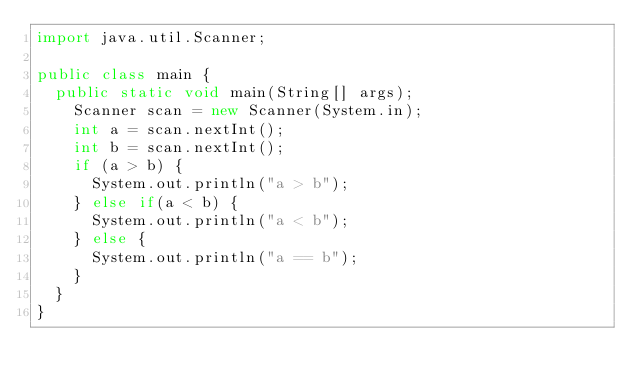Convert code to text. <code><loc_0><loc_0><loc_500><loc_500><_Java_>import java.util.Scanner;
  
public class main {
  public static void main(String[] args);
    Scanner scan = new Scanner(System.in);
    int a = scan.nextInt();
    int b = scan.nextInt();
    if (a > b) {
      System.out.println("a > b");
    } else if(a < b) {
      System.out.println("a < b");
    } else {
      System.out.println("a == b");
    }
  }
}</code> 